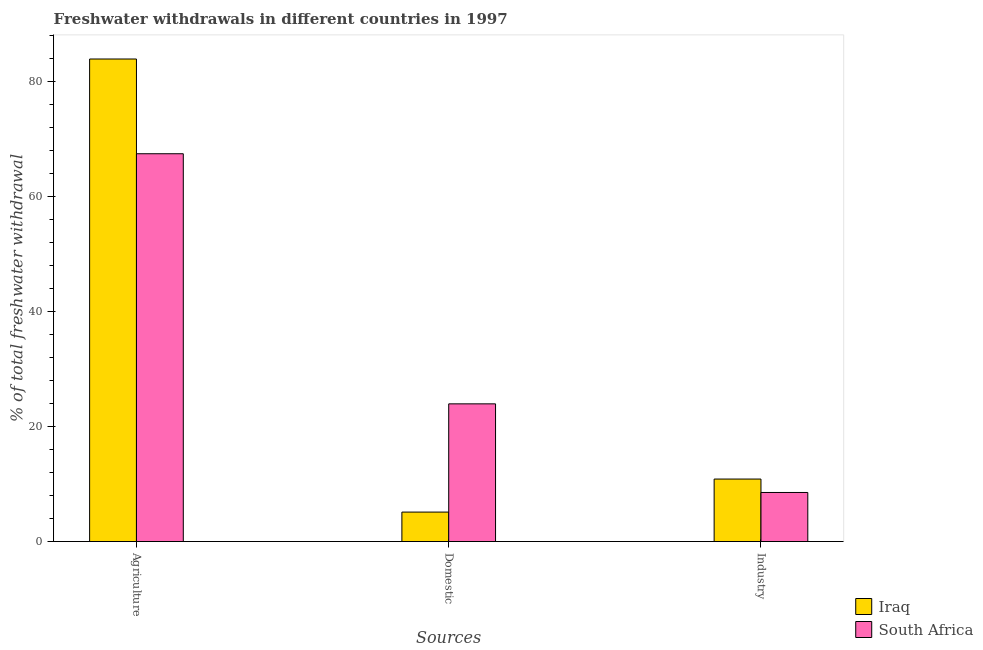What is the label of the 2nd group of bars from the left?
Your response must be concise. Domestic. What is the percentage of freshwater withdrawal for agriculture in Iraq?
Keep it short and to the point. 83.99. Across all countries, what is the maximum percentage of freshwater withdrawal for domestic purposes?
Provide a short and direct response. 23.97. Across all countries, what is the minimum percentage of freshwater withdrawal for industry?
Offer a terse response. 8.54. In which country was the percentage of freshwater withdrawal for agriculture maximum?
Provide a short and direct response. Iraq. In which country was the percentage of freshwater withdrawal for agriculture minimum?
Provide a succinct answer. South Africa. What is the total percentage of freshwater withdrawal for agriculture in the graph?
Keep it short and to the point. 151.49. What is the difference between the percentage of freshwater withdrawal for domestic purposes in South Africa and that in Iraq?
Your answer should be compact. 18.84. What is the difference between the percentage of freshwater withdrawal for domestic purposes in Iraq and the percentage of freshwater withdrawal for agriculture in South Africa?
Offer a terse response. -62.37. What is the average percentage of freshwater withdrawal for agriculture per country?
Ensure brevity in your answer.  75.75. What is the difference between the percentage of freshwater withdrawal for agriculture and percentage of freshwater withdrawal for domestic purposes in Iraq?
Provide a short and direct response. 78.86. In how many countries, is the percentage of freshwater withdrawal for agriculture greater than 64 %?
Provide a short and direct response. 2. What is the ratio of the percentage of freshwater withdrawal for industry in South Africa to that in Iraq?
Provide a succinct answer. 0.79. Is the difference between the percentage of freshwater withdrawal for agriculture in Iraq and South Africa greater than the difference between the percentage of freshwater withdrawal for industry in Iraq and South Africa?
Provide a succinct answer. Yes. What is the difference between the highest and the second highest percentage of freshwater withdrawal for industry?
Ensure brevity in your answer.  2.34. What is the difference between the highest and the lowest percentage of freshwater withdrawal for domestic purposes?
Offer a terse response. 18.84. What does the 2nd bar from the left in Domestic represents?
Your answer should be very brief. South Africa. What does the 1st bar from the right in Industry represents?
Offer a very short reply. South Africa. Are all the bars in the graph horizontal?
Your response must be concise. No. How many countries are there in the graph?
Provide a short and direct response. 2. Does the graph contain any zero values?
Provide a short and direct response. No. Does the graph contain grids?
Your response must be concise. No. How many legend labels are there?
Offer a very short reply. 2. How are the legend labels stacked?
Offer a terse response. Vertical. What is the title of the graph?
Your answer should be very brief. Freshwater withdrawals in different countries in 1997. Does "Caribbean small states" appear as one of the legend labels in the graph?
Give a very brief answer. No. What is the label or title of the X-axis?
Keep it short and to the point. Sources. What is the label or title of the Y-axis?
Make the answer very short. % of total freshwater withdrawal. What is the % of total freshwater withdrawal of Iraq in Agriculture?
Offer a terse response. 83.99. What is the % of total freshwater withdrawal of South Africa in Agriculture?
Provide a succinct answer. 67.5. What is the % of total freshwater withdrawal in Iraq in Domestic?
Your response must be concise. 5.13. What is the % of total freshwater withdrawal in South Africa in Domestic?
Your answer should be compact. 23.97. What is the % of total freshwater withdrawal in Iraq in Industry?
Offer a terse response. 10.88. What is the % of total freshwater withdrawal of South Africa in Industry?
Your answer should be very brief. 8.54. Across all Sources, what is the maximum % of total freshwater withdrawal in Iraq?
Your response must be concise. 83.99. Across all Sources, what is the maximum % of total freshwater withdrawal of South Africa?
Make the answer very short. 67.5. Across all Sources, what is the minimum % of total freshwater withdrawal of Iraq?
Ensure brevity in your answer.  5.13. Across all Sources, what is the minimum % of total freshwater withdrawal in South Africa?
Provide a short and direct response. 8.54. What is the total % of total freshwater withdrawal in Iraq in the graph?
Provide a succinct answer. 100. What is the total % of total freshwater withdrawal of South Africa in the graph?
Offer a very short reply. 100.01. What is the difference between the % of total freshwater withdrawal of Iraq in Agriculture and that in Domestic?
Give a very brief answer. 78.86. What is the difference between the % of total freshwater withdrawal of South Africa in Agriculture and that in Domestic?
Give a very brief answer. 43.53. What is the difference between the % of total freshwater withdrawal in Iraq in Agriculture and that in Industry?
Give a very brief answer. 73.11. What is the difference between the % of total freshwater withdrawal in South Africa in Agriculture and that in Industry?
Provide a short and direct response. 58.96. What is the difference between the % of total freshwater withdrawal in Iraq in Domestic and that in Industry?
Your answer should be compact. -5.75. What is the difference between the % of total freshwater withdrawal in South Africa in Domestic and that in Industry?
Make the answer very short. 15.43. What is the difference between the % of total freshwater withdrawal in Iraq in Agriculture and the % of total freshwater withdrawal in South Africa in Domestic?
Keep it short and to the point. 60.02. What is the difference between the % of total freshwater withdrawal in Iraq in Agriculture and the % of total freshwater withdrawal in South Africa in Industry?
Offer a terse response. 75.45. What is the difference between the % of total freshwater withdrawal of Iraq in Domestic and the % of total freshwater withdrawal of South Africa in Industry?
Ensure brevity in your answer.  -3.41. What is the average % of total freshwater withdrawal in Iraq per Sources?
Give a very brief answer. 33.33. What is the average % of total freshwater withdrawal in South Africa per Sources?
Your answer should be compact. 33.34. What is the difference between the % of total freshwater withdrawal in Iraq and % of total freshwater withdrawal in South Africa in Agriculture?
Your response must be concise. 16.49. What is the difference between the % of total freshwater withdrawal in Iraq and % of total freshwater withdrawal in South Africa in Domestic?
Provide a short and direct response. -18.84. What is the difference between the % of total freshwater withdrawal of Iraq and % of total freshwater withdrawal of South Africa in Industry?
Your answer should be compact. 2.34. What is the ratio of the % of total freshwater withdrawal of Iraq in Agriculture to that in Domestic?
Give a very brief answer. 16.38. What is the ratio of the % of total freshwater withdrawal in South Africa in Agriculture to that in Domestic?
Offer a very short reply. 2.82. What is the ratio of the % of total freshwater withdrawal of Iraq in Agriculture to that in Industry?
Ensure brevity in your answer.  7.72. What is the ratio of the % of total freshwater withdrawal in South Africa in Agriculture to that in Industry?
Your answer should be very brief. 7.9. What is the ratio of the % of total freshwater withdrawal of Iraq in Domestic to that in Industry?
Offer a very short reply. 0.47. What is the ratio of the % of total freshwater withdrawal in South Africa in Domestic to that in Industry?
Provide a succinct answer. 2.81. What is the difference between the highest and the second highest % of total freshwater withdrawal of Iraq?
Your answer should be compact. 73.11. What is the difference between the highest and the second highest % of total freshwater withdrawal in South Africa?
Make the answer very short. 43.53. What is the difference between the highest and the lowest % of total freshwater withdrawal in Iraq?
Keep it short and to the point. 78.86. What is the difference between the highest and the lowest % of total freshwater withdrawal of South Africa?
Your answer should be very brief. 58.96. 